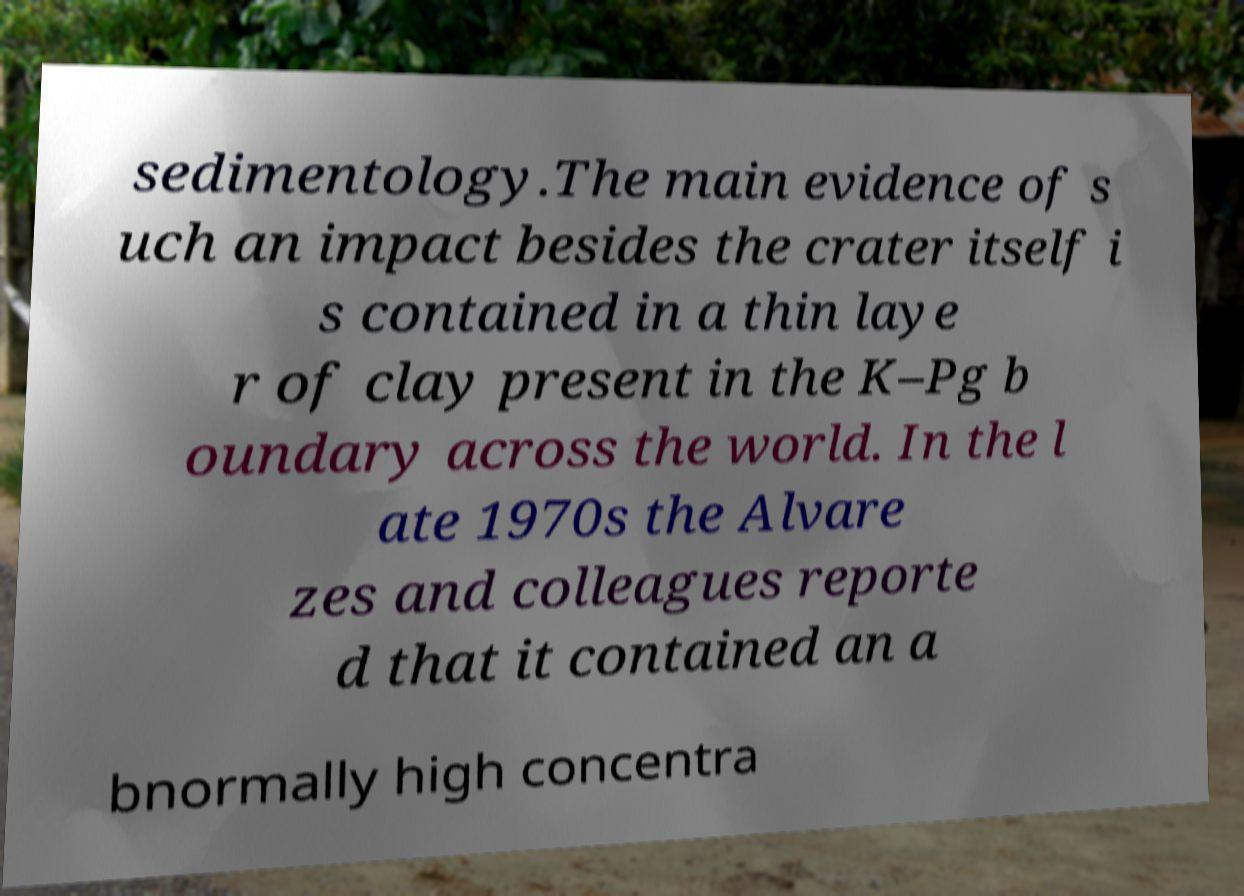For documentation purposes, I need the text within this image transcribed. Could you provide that? sedimentology.The main evidence of s uch an impact besides the crater itself i s contained in a thin laye r of clay present in the K–Pg b oundary across the world. In the l ate 1970s the Alvare zes and colleagues reporte d that it contained an a bnormally high concentra 